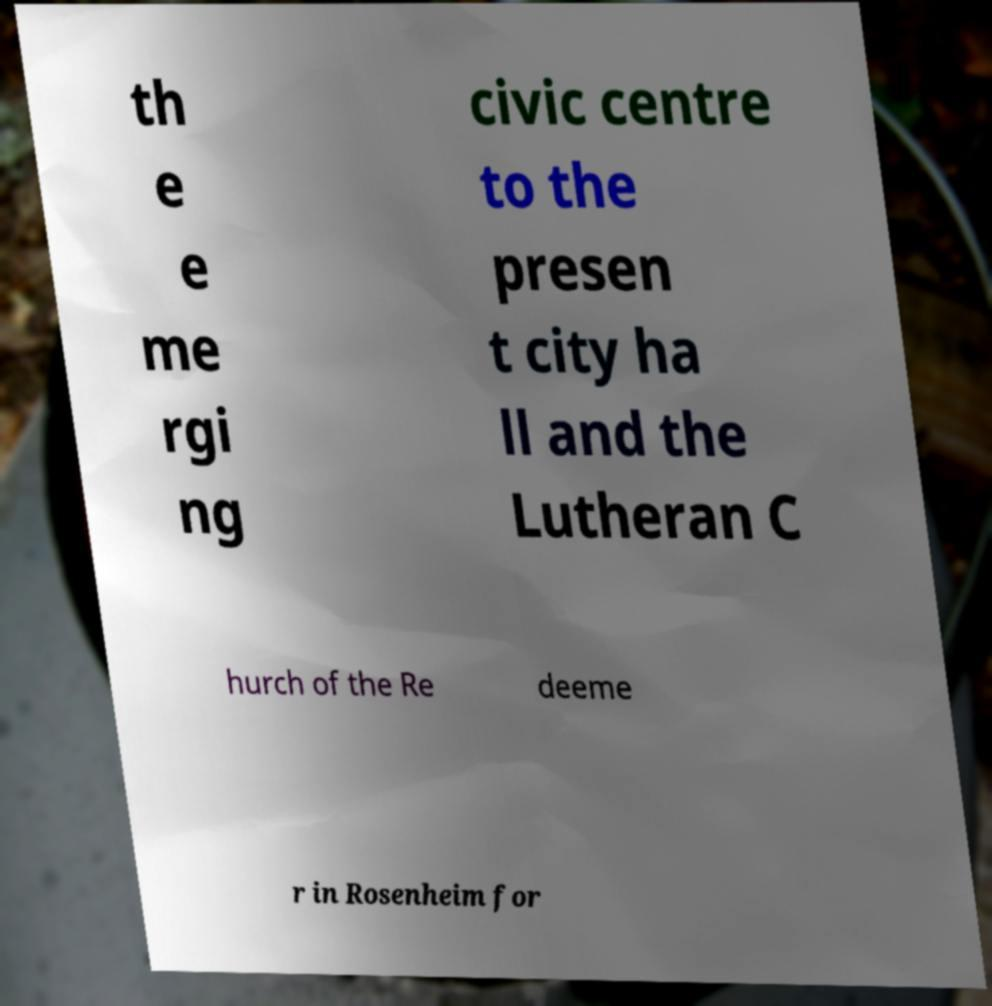Please read and relay the text visible in this image. What does it say? th e e me rgi ng civic centre to the presen t city ha ll and the Lutheran C hurch of the Re deeme r in Rosenheim for 